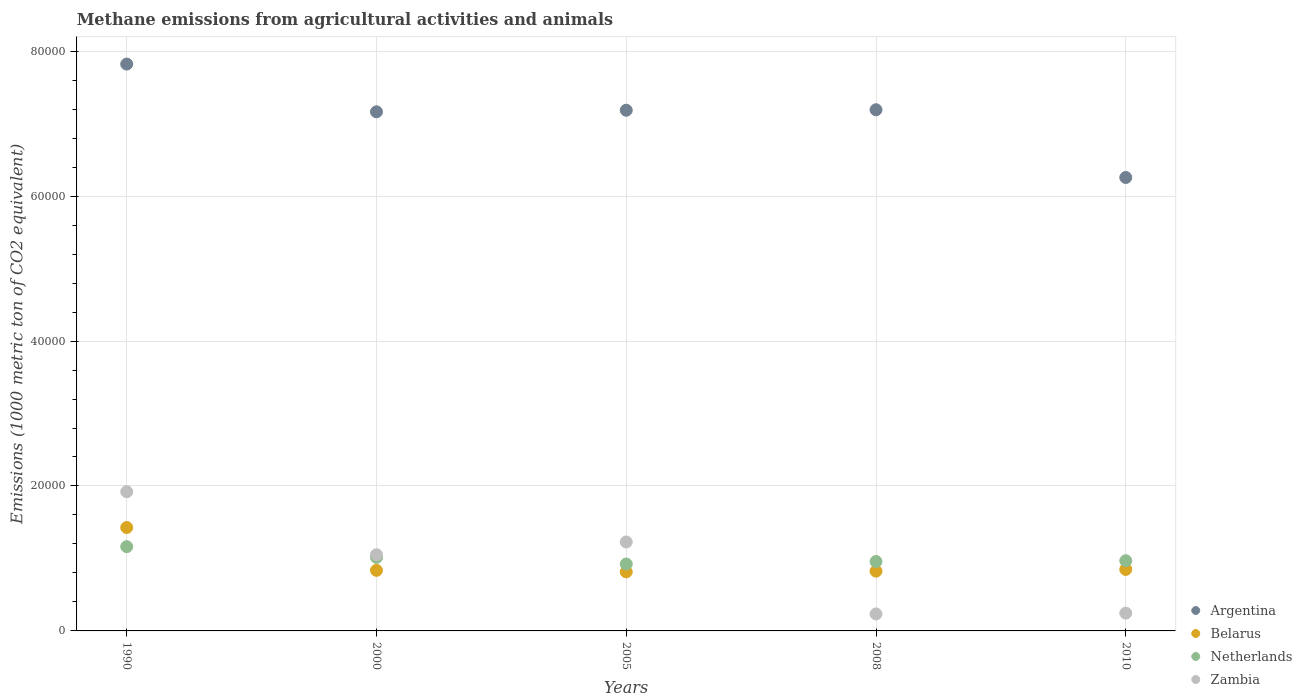What is the amount of methane emitted in Zambia in 2010?
Give a very brief answer. 2457.2. Across all years, what is the maximum amount of methane emitted in Zambia?
Provide a succinct answer. 1.92e+04. Across all years, what is the minimum amount of methane emitted in Netherlands?
Offer a very short reply. 9228. What is the total amount of methane emitted in Belarus in the graph?
Make the answer very short. 4.75e+04. What is the difference between the amount of methane emitted in Argentina in 1990 and that in 2000?
Your response must be concise. 6588.6. What is the difference between the amount of methane emitted in Zambia in 1990 and the amount of methane emitted in Netherlands in 2005?
Your answer should be compact. 9979.1. What is the average amount of methane emitted in Netherlands per year?
Keep it short and to the point. 1.01e+04. In the year 2005, what is the difference between the amount of methane emitted in Netherlands and amount of methane emitted in Zambia?
Make the answer very short. -3046.5. In how many years, is the amount of methane emitted in Argentina greater than 36000 1000 metric ton?
Provide a short and direct response. 5. What is the ratio of the amount of methane emitted in Argentina in 1990 to that in 2010?
Your response must be concise. 1.25. Is the amount of methane emitted in Netherlands in 2005 less than that in 2008?
Your answer should be compact. Yes. What is the difference between the highest and the second highest amount of methane emitted in Zambia?
Make the answer very short. 6932.6. What is the difference between the highest and the lowest amount of methane emitted in Belarus?
Give a very brief answer. 6122.6. In how many years, is the amount of methane emitted in Netherlands greater than the average amount of methane emitted in Netherlands taken over all years?
Give a very brief answer. 2. Is the sum of the amount of methane emitted in Belarus in 2005 and 2010 greater than the maximum amount of methane emitted in Argentina across all years?
Offer a very short reply. No. Is it the case that in every year, the sum of the amount of methane emitted in Argentina and amount of methane emitted in Zambia  is greater than the amount of methane emitted in Netherlands?
Your answer should be compact. Yes. Is the amount of methane emitted in Belarus strictly greater than the amount of methane emitted in Netherlands over the years?
Your response must be concise. No. Is the amount of methane emitted in Argentina strictly less than the amount of methane emitted in Zambia over the years?
Your answer should be very brief. No. How many years are there in the graph?
Provide a short and direct response. 5. Are the values on the major ticks of Y-axis written in scientific E-notation?
Your answer should be compact. No. Does the graph contain any zero values?
Make the answer very short. No. How many legend labels are there?
Your response must be concise. 4. What is the title of the graph?
Your response must be concise. Methane emissions from agricultural activities and animals. What is the label or title of the Y-axis?
Ensure brevity in your answer.  Emissions (1000 metric ton of CO2 equivalent). What is the Emissions (1000 metric ton of CO2 equivalent) of Argentina in 1990?
Your answer should be compact. 7.82e+04. What is the Emissions (1000 metric ton of CO2 equivalent) of Belarus in 1990?
Ensure brevity in your answer.  1.43e+04. What is the Emissions (1000 metric ton of CO2 equivalent) in Netherlands in 1990?
Offer a terse response. 1.16e+04. What is the Emissions (1000 metric ton of CO2 equivalent) in Zambia in 1990?
Your response must be concise. 1.92e+04. What is the Emissions (1000 metric ton of CO2 equivalent) of Argentina in 2000?
Ensure brevity in your answer.  7.16e+04. What is the Emissions (1000 metric ton of CO2 equivalent) in Belarus in 2000?
Ensure brevity in your answer.  8360.4. What is the Emissions (1000 metric ton of CO2 equivalent) of Netherlands in 2000?
Give a very brief answer. 1.01e+04. What is the Emissions (1000 metric ton of CO2 equivalent) of Zambia in 2000?
Ensure brevity in your answer.  1.05e+04. What is the Emissions (1000 metric ton of CO2 equivalent) in Argentina in 2005?
Ensure brevity in your answer.  7.19e+04. What is the Emissions (1000 metric ton of CO2 equivalent) of Belarus in 2005?
Your answer should be compact. 8147.7. What is the Emissions (1000 metric ton of CO2 equivalent) in Netherlands in 2005?
Provide a succinct answer. 9228. What is the Emissions (1000 metric ton of CO2 equivalent) in Zambia in 2005?
Provide a succinct answer. 1.23e+04. What is the Emissions (1000 metric ton of CO2 equivalent) of Argentina in 2008?
Your answer should be compact. 7.19e+04. What is the Emissions (1000 metric ton of CO2 equivalent) in Belarus in 2008?
Your answer should be compact. 8252. What is the Emissions (1000 metric ton of CO2 equivalent) of Netherlands in 2008?
Offer a terse response. 9574.5. What is the Emissions (1000 metric ton of CO2 equivalent) of Zambia in 2008?
Make the answer very short. 2342.5. What is the Emissions (1000 metric ton of CO2 equivalent) in Argentina in 2010?
Provide a short and direct response. 6.26e+04. What is the Emissions (1000 metric ton of CO2 equivalent) in Belarus in 2010?
Offer a very short reply. 8487.5. What is the Emissions (1000 metric ton of CO2 equivalent) in Netherlands in 2010?
Your answer should be compact. 9687.8. What is the Emissions (1000 metric ton of CO2 equivalent) of Zambia in 2010?
Offer a terse response. 2457.2. Across all years, what is the maximum Emissions (1000 metric ton of CO2 equivalent) in Argentina?
Provide a succinct answer. 7.82e+04. Across all years, what is the maximum Emissions (1000 metric ton of CO2 equivalent) of Belarus?
Provide a succinct answer. 1.43e+04. Across all years, what is the maximum Emissions (1000 metric ton of CO2 equivalent) in Netherlands?
Make the answer very short. 1.16e+04. Across all years, what is the maximum Emissions (1000 metric ton of CO2 equivalent) in Zambia?
Give a very brief answer. 1.92e+04. Across all years, what is the minimum Emissions (1000 metric ton of CO2 equivalent) of Argentina?
Provide a short and direct response. 6.26e+04. Across all years, what is the minimum Emissions (1000 metric ton of CO2 equivalent) in Belarus?
Your answer should be compact. 8147.7. Across all years, what is the minimum Emissions (1000 metric ton of CO2 equivalent) of Netherlands?
Keep it short and to the point. 9228. Across all years, what is the minimum Emissions (1000 metric ton of CO2 equivalent) of Zambia?
Offer a terse response. 2342.5. What is the total Emissions (1000 metric ton of CO2 equivalent) of Argentina in the graph?
Keep it short and to the point. 3.56e+05. What is the total Emissions (1000 metric ton of CO2 equivalent) in Belarus in the graph?
Offer a very short reply. 4.75e+04. What is the total Emissions (1000 metric ton of CO2 equivalent) in Netherlands in the graph?
Provide a succinct answer. 5.03e+04. What is the total Emissions (1000 metric ton of CO2 equivalent) of Zambia in the graph?
Provide a succinct answer. 4.68e+04. What is the difference between the Emissions (1000 metric ton of CO2 equivalent) of Argentina in 1990 and that in 2000?
Give a very brief answer. 6588.6. What is the difference between the Emissions (1000 metric ton of CO2 equivalent) of Belarus in 1990 and that in 2000?
Provide a succinct answer. 5909.9. What is the difference between the Emissions (1000 metric ton of CO2 equivalent) of Netherlands in 1990 and that in 2000?
Your answer should be very brief. 1481.2. What is the difference between the Emissions (1000 metric ton of CO2 equivalent) of Zambia in 1990 and that in 2000?
Ensure brevity in your answer.  8698.2. What is the difference between the Emissions (1000 metric ton of CO2 equivalent) of Argentina in 1990 and that in 2005?
Offer a terse response. 6369.6. What is the difference between the Emissions (1000 metric ton of CO2 equivalent) of Belarus in 1990 and that in 2005?
Give a very brief answer. 6122.6. What is the difference between the Emissions (1000 metric ton of CO2 equivalent) in Netherlands in 1990 and that in 2005?
Keep it short and to the point. 2398. What is the difference between the Emissions (1000 metric ton of CO2 equivalent) of Zambia in 1990 and that in 2005?
Provide a short and direct response. 6932.6. What is the difference between the Emissions (1000 metric ton of CO2 equivalent) in Argentina in 1990 and that in 2008?
Your answer should be very brief. 6305.5. What is the difference between the Emissions (1000 metric ton of CO2 equivalent) in Belarus in 1990 and that in 2008?
Your answer should be very brief. 6018.3. What is the difference between the Emissions (1000 metric ton of CO2 equivalent) in Netherlands in 1990 and that in 2008?
Your answer should be compact. 2051.5. What is the difference between the Emissions (1000 metric ton of CO2 equivalent) in Zambia in 1990 and that in 2008?
Offer a very short reply. 1.69e+04. What is the difference between the Emissions (1000 metric ton of CO2 equivalent) of Argentina in 1990 and that in 2010?
Make the answer very short. 1.57e+04. What is the difference between the Emissions (1000 metric ton of CO2 equivalent) of Belarus in 1990 and that in 2010?
Give a very brief answer. 5782.8. What is the difference between the Emissions (1000 metric ton of CO2 equivalent) of Netherlands in 1990 and that in 2010?
Provide a short and direct response. 1938.2. What is the difference between the Emissions (1000 metric ton of CO2 equivalent) in Zambia in 1990 and that in 2010?
Keep it short and to the point. 1.67e+04. What is the difference between the Emissions (1000 metric ton of CO2 equivalent) in Argentina in 2000 and that in 2005?
Your answer should be compact. -219. What is the difference between the Emissions (1000 metric ton of CO2 equivalent) of Belarus in 2000 and that in 2005?
Keep it short and to the point. 212.7. What is the difference between the Emissions (1000 metric ton of CO2 equivalent) in Netherlands in 2000 and that in 2005?
Provide a succinct answer. 916.8. What is the difference between the Emissions (1000 metric ton of CO2 equivalent) in Zambia in 2000 and that in 2005?
Provide a short and direct response. -1765.6. What is the difference between the Emissions (1000 metric ton of CO2 equivalent) of Argentina in 2000 and that in 2008?
Give a very brief answer. -283.1. What is the difference between the Emissions (1000 metric ton of CO2 equivalent) of Belarus in 2000 and that in 2008?
Your answer should be very brief. 108.4. What is the difference between the Emissions (1000 metric ton of CO2 equivalent) of Netherlands in 2000 and that in 2008?
Your response must be concise. 570.3. What is the difference between the Emissions (1000 metric ton of CO2 equivalent) of Zambia in 2000 and that in 2008?
Offer a very short reply. 8166.4. What is the difference between the Emissions (1000 metric ton of CO2 equivalent) of Argentina in 2000 and that in 2010?
Your response must be concise. 9062.7. What is the difference between the Emissions (1000 metric ton of CO2 equivalent) in Belarus in 2000 and that in 2010?
Your answer should be very brief. -127.1. What is the difference between the Emissions (1000 metric ton of CO2 equivalent) in Netherlands in 2000 and that in 2010?
Keep it short and to the point. 457. What is the difference between the Emissions (1000 metric ton of CO2 equivalent) of Zambia in 2000 and that in 2010?
Provide a short and direct response. 8051.7. What is the difference between the Emissions (1000 metric ton of CO2 equivalent) of Argentina in 2005 and that in 2008?
Provide a succinct answer. -64.1. What is the difference between the Emissions (1000 metric ton of CO2 equivalent) in Belarus in 2005 and that in 2008?
Your answer should be compact. -104.3. What is the difference between the Emissions (1000 metric ton of CO2 equivalent) in Netherlands in 2005 and that in 2008?
Provide a short and direct response. -346.5. What is the difference between the Emissions (1000 metric ton of CO2 equivalent) in Zambia in 2005 and that in 2008?
Provide a succinct answer. 9932. What is the difference between the Emissions (1000 metric ton of CO2 equivalent) of Argentina in 2005 and that in 2010?
Provide a short and direct response. 9281.7. What is the difference between the Emissions (1000 metric ton of CO2 equivalent) of Belarus in 2005 and that in 2010?
Ensure brevity in your answer.  -339.8. What is the difference between the Emissions (1000 metric ton of CO2 equivalent) of Netherlands in 2005 and that in 2010?
Offer a very short reply. -459.8. What is the difference between the Emissions (1000 metric ton of CO2 equivalent) of Zambia in 2005 and that in 2010?
Provide a short and direct response. 9817.3. What is the difference between the Emissions (1000 metric ton of CO2 equivalent) in Argentina in 2008 and that in 2010?
Your response must be concise. 9345.8. What is the difference between the Emissions (1000 metric ton of CO2 equivalent) of Belarus in 2008 and that in 2010?
Make the answer very short. -235.5. What is the difference between the Emissions (1000 metric ton of CO2 equivalent) in Netherlands in 2008 and that in 2010?
Keep it short and to the point. -113.3. What is the difference between the Emissions (1000 metric ton of CO2 equivalent) of Zambia in 2008 and that in 2010?
Your answer should be compact. -114.7. What is the difference between the Emissions (1000 metric ton of CO2 equivalent) of Argentina in 1990 and the Emissions (1000 metric ton of CO2 equivalent) of Belarus in 2000?
Keep it short and to the point. 6.99e+04. What is the difference between the Emissions (1000 metric ton of CO2 equivalent) of Argentina in 1990 and the Emissions (1000 metric ton of CO2 equivalent) of Netherlands in 2000?
Offer a very short reply. 6.81e+04. What is the difference between the Emissions (1000 metric ton of CO2 equivalent) of Argentina in 1990 and the Emissions (1000 metric ton of CO2 equivalent) of Zambia in 2000?
Ensure brevity in your answer.  6.77e+04. What is the difference between the Emissions (1000 metric ton of CO2 equivalent) in Belarus in 1990 and the Emissions (1000 metric ton of CO2 equivalent) in Netherlands in 2000?
Keep it short and to the point. 4125.5. What is the difference between the Emissions (1000 metric ton of CO2 equivalent) of Belarus in 1990 and the Emissions (1000 metric ton of CO2 equivalent) of Zambia in 2000?
Provide a succinct answer. 3761.4. What is the difference between the Emissions (1000 metric ton of CO2 equivalent) of Netherlands in 1990 and the Emissions (1000 metric ton of CO2 equivalent) of Zambia in 2000?
Ensure brevity in your answer.  1117.1. What is the difference between the Emissions (1000 metric ton of CO2 equivalent) of Argentina in 1990 and the Emissions (1000 metric ton of CO2 equivalent) of Belarus in 2005?
Offer a terse response. 7.01e+04. What is the difference between the Emissions (1000 metric ton of CO2 equivalent) in Argentina in 1990 and the Emissions (1000 metric ton of CO2 equivalent) in Netherlands in 2005?
Offer a very short reply. 6.90e+04. What is the difference between the Emissions (1000 metric ton of CO2 equivalent) in Argentina in 1990 and the Emissions (1000 metric ton of CO2 equivalent) in Zambia in 2005?
Give a very brief answer. 6.59e+04. What is the difference between the Emissions (1000 metric ton of CO2 equivalent) of Belarus in 1990 and the Emissions (1000 metric ton of CO2 equivalent) of Netherlands in 2005?
Offer a very short reply. 5042.3. What is the difference between the Emissions (1000 metric ton of CO2 equivalent) in Belarus in 1990 and the Emissions (1000 metric ton of CO2 equivalent) in Zambia in 2005?
Offer a terse response. 1995.8. What is the difference between the Emissions (1000 metric ton of CO2 equivalent) in Netherlands in 1990 and the Emissions (1000 metric ton of CO2 equivalent) in Zambia in 2005?
Give a very brief answer. -648.5. What is the difference between the Emissions (1000 metric ton of CO2 equivalent) of Argentina in 1990 and the Emissions (1000 metric ton of CO2 equivalent) of Belarus in 2008?
Offer a very short reply. 7.00e+04. What is the difference between the Emissions (1000 metric ton of CO2 equivalent) of Argentina in 1990 and the Emissions (1000 metric ton of CO2 equivalent) of Netherlands in 2008?
Make the answer very short. 6.86e+04. What is the difference between the Emissions (1000 metric ton of CO2 equivalent) of Argentina in 1990 and the Emissions (1000 metric ton of CO2 equivalent) of Zambia in 2008?
Offer a terse response. 7.59e+04. What is the difference between the Emissions (1000 metric ton of CO2 equivalent) in Belarus in 1990 and the Emissions (1000 metric ton of CO2 equivalent) in Netherlands in 2008?
Your answer should be very brief. 4695.8. What is the difference between the Emissions (1000 metric ton of CO2 equivalent) of Belarus in 1990 and the Emissions (1000 metric ton of CO2 equivalent) of Zambia in 2008?
Your answer should be compact. 1.19e+04. What is the difference between the Emissions (1000 metric ton of CO2 equivalent) in Netherlands in 1990 and the Emissions (1000 metric ton of CO2 equivalent) in Zambia in 2008?
Give a very brief answer. 9283.5. What is the difference between the Emissions (1000 metric ton of CO2 equivalent) in Argentina in 1990 and the Emissions (1000 metric ton of CO2 equivalent) in Belarus in 2010?
Provide a succinct answer. 6.97e+04. What is the difference between the Emissions (1000 metric ton of CO2 equivalent) of Argentina in 1990 and the Emissions (1000 metric ton of CO2 equivalent) of Netherlands in 2010?
Provide a short and direct response. 6.85e+04. What is the difference between the Emissions (1000 metric ton of CO2 equivalent) in Argentina in 1990 and the Emissions (1000 metric ton of CO2 equivalent) in Zambia in 2010?
Provide a succinct answer. 7.58e+04. What is the difference between the Emissions (1000 metric ton of CO2 equivalent) of Belarus in 1990 and the Emissions (1000 metric ton of CO2 equivalent) of Netherlands in 2010?
Make the answer very short. 4582.5. What is the difference between the Emissions (1000 metric ton of CO2 equivalent) in Belarus in 1990 and the Emissions (1000 metric ton of CO2 equivalent) in Zambia in 2010?
Provide a short and direct response. 1.18e+04. What is the difference between the Emissions (1000 metric ton of CO2 equivalent) of Netherlands in 1990 and the Emissions (1000 metric ton of CO2 equivalent) of Zambia in 2010?
Your answer should be very brief. 9168.8. What is the difference between the Emissions (1000 metric ton of CO2 equivalent) in Argentina in 2000 and the Emissions (1000 metric ton of CO2 equivalent) in Belarus in 2005?
Offer a terse response. 6.35e+04. What is the difference between the Emissions (1000 metric ton of CO2 equivalent) of Argentina in 2000 and the Emissions (1000 metric ton of CO2 equivalent) of Netherlands in 2005?
Provide a succinct answer. 6.24e+04. What is the difference between the Emissions (1000 metric ton of CO2 equivalent) in Argentina in 2000 and the Emissions (1000 metric ton of CO2 equivalent) in Zambia in 2005?
Your answer should be very brief. 5.94e+04. What is the difference between the Emissions (1000 metric ton of CO2 equivalent) in Belarus in 2000 and the Emissions (1000 metric ton of CO2 equivalent) in Netherlands in 2005?
Your answer should be very brief. -867.6. What is the difference between the Emissions (1000 metric ton of CO2 equivalent) of Belarus in 2000 and the Emissions (1000 metric ton of CO2 equivalent) of Zambia in 2005?
Your answer should be very brief. -3914.1. What is the difference between the Emissions (1000 metric ton of CO2 equivalent) of Netherlands in 2000 and the Emissions (1000 metric ton of CO2 equivalent) of Zambia in 2005?
Make the answer very short. -2129.7. What is the difference between the Emissions (1000 metric ton of CO2 equivalent) of Argentina in 2000 and the Emissions (1000 metric ton of CO2 equivalent) of Belarus in 2008?
Offer a terse response. 6.34e+04. What is the difference between the Emissions (1000 metric ton of CO2 equivalent) of Argentina in 2000 and the Emissions (1000 metric ton of CO2 equivalent) of Netherlands in 2008?
Offer a very short reply. 6.21e+04. What is the difference between the Emissions (1000 metric ton of CO2 equivalent) in Argentina in 2000 and the Emissions (1000 metric ton of CO2 equivalent) in Zambia in 2008?
Ensure brevity in your answer.  6.93e+04. What is the difference between the Emissions (1000 metric ton of CO2 equivalent) of Belarus in 2000 and the Emissions (1000 metric ton of CO2 equivalent) of Netherlands in 2008?
Give a very brief answer. -1214.1. What is the difference between the Emissions (1000 metric ton of CO2 equivalent) in Belarus in 2000 and the Emissions (1000 metric ton of CO2 equivalent) in Zambia in 2008?
Offer a very short reply. 6017.9. What is the difference between the Emissions (1000 metric ton of CO2 equivalent) in Netherlands in 2000 and the Emissions (1000 metric ton of CO2 equivalent) in Zambia in 2008?
Your response must be concise. 7802.3. What is the difference between the Emissions (1000 metric ton of CO2 equivalent) in Argentina in 2000 and the Emissions (1000 metric ton of CO2 equivalent) in Belarus in 2010?
Give a very brief answer. 6.31e+04. What is the difference between the Emissions (1000 metric ton of CO2 equivalent) in Argentina in 2000 and the Emissions (1000 metric ton of CO2 equivalent) in Netherlands in 2010?
Provide a succinct answer. 6.19e+04. What is the difference between the Emissions (1000 metric ton of CO2 equivalent) of Argentina in 2000 and the Emissions (1000 metric ton of CO2 equivalent) of Zambia in 2010?
Give a very brief answer. 6.92e+04. What is the difference between the Emissions (1000 metric ton of CO2 equivalent) of Belarus in 2000 and the Emissions (1000 metric ton of CO2 equivalent) of Netherlands in 2010?
Keep it short and to the point. -1327.4. What is the difference between the Emissions (1000 metric ton of CO2 equivalent) of Belarus in 2000 and the Emissions (1000 metric ton of CO2 equivalent) of Zambia in 2010?
Provide a succinct answer. 5903.2. What is the difference between the Emissions (1000 metric ton of CO2 equivalent) in Netherlands in 2000 and the Emissions (1000 metric ton of CO2 equivalent) in Zambia in 2010?
Offer a very short reply. 7687.6. What is the difference between the Emissions (1000 metric ton of CO2 equivalent) of Argentina in 2005 and the Emissions (1000 metric ton of CO2 equivalent) of Belarus in 2008?
Offer a very short reply. 6.36e+04. What is the difference between the Emissions (1000 metric ton of CO2 equivalent) in Argentina in 2005 and the Emissions (1000 metric ton of CO2 equivalent) in Netherlands in 2008?
Provide a succinct answer. 6.23e+04. What is the difference between the Emissions (1000 metric ton of CO2 equivalent) in Argentina in 2005 and the Emissions (1000 metric ton of CO2 equivalent) in Zambia in 2008?
Make the answer very short. 6.95e+04. What is the difference between the Emissions (1000 metric ton of CO2 equivalent) of Belarus in 2005 and the Emissions (1000 metric ton of CO2 equivalent) of Netherlands in 2008?
Keep it short and to the point. -1426.8. What is the difference between the Emissions (1000 metric ton of CO2 equivalent) in Belarus in 2005 and the Emissions (1000 metric ton of CO2 equivalent) in Zambia in 2008?
Keep it short and to the point. 5805.2. What is the difference between the Emissions (1000 metric ton of CO2 equivalent) of Netherlands in 2005 and the Emissions (1000 metric ton of CO2 equivalent) of Zambia in 2008?
Give a very brief answer. 6885.5. What is the difference between the Emissions (1000 metric ton of CO2 equivalent) in Argentina in 2005 and the Emissions (1000 metric ton of CO2 equivalent) in Belarus in 2010?
Give a very brief answer. 6.34e+04. What is the difference between the Emissions (1000 metric ton of CO2 equivalent) in Argentina in 2005 and the Emissions (1000 metric ton of CO2 equivalent) in Netherlands in 2010?
Keep it short and to the point. 6.22e+04. What is the difference between the Emissions (1000 metric ton of CO2 equivalent) of Argentina in 2005 and the Emissions (1000 metric ton of CO2 equivalent) of Zambia in 2010?
Make the answer very short. 6.94e+04. What is the difference between the Emissions (1000 metric ton of CO2 equivalent) in Belarus in 2005 and the Emissions (1000 metric ton of CO2 equivalent) in Netherlands in 2010?
Ensure brevity in your answer.  -1540.1. What is the difference between the Emissions (1000 metric ton of CO2 equivalent) of Belarus in 2005 and the Emissions (1000 metric ton of CO2 equivalent) of Zambia in 2010?
Keep it short and to the point. 5690.5. What is the difference between the Emissions (1000 metric ton of CO2 equivalent) of Netherlands in 2005 and the Emissions (1000 metric ton of CO2 equivalent) of Zambia in 2010?
Ensure brevity in your answer.  6770.8. What is the difference between the Emissions (1000 metric ton of CO2 equivalent) of Argentina in 2008 and the Emissions (1000 metric ton of CO2 equivalent) of Belarus in 2010?
Make the answer very short. 6.34e+04. What is the difference between the Emissions (1000 metric ton of CO2 equivalent) of Argentina in 2008 and the Emissions (1000 metric ton of CO2 equivalent) of Netherlands in 2010?
Your answer should be compact. 6.22e+04. What is the difference between the Emissions (1000 metric ton of CO2 equivalent) of Argentina in 2008 and the Emissions (1000 metric ton of CO2 equivalent) of Zambia in 2010?
Your response must be concise. 6.95e+04. What is the difference between the Emissions (1000 metric ton of CO2 equivalent) in Belarus in 2008 and the Emissions (1000 metric ton of CO2 equivalent) in Netherlands in 2010?
Ensure brevity in your answer.  -1435.8. What is the difference between the Emissions (1000 metric ton of CO2 equivalent) of Belarus in 2008 and the Emissions (1000 metric ton of CO2 equivalent) of Zambia in 2010?
Ensure brevity in your answer.  5794.8. What is the difference between the Emissions (1000 metric ton of CO2 equivalent) of Netherlands in 2008 and the Emissions (1000 metric ton of CO2 equivalent) of Zambia in 2010?
Offer a very short reply. 7117.3. What is the average Emissions (1000 metric ton of CO2 equivalent) of Argentina per year?
Your answer should be compact. 7.12e+04. What is the average Emissions (1000 metric ton of CO2 equivalent) in Belarus per year?
Your response must be concise. 9503.58. What is the average Emissions (1000 metric ton of CO2 equivalent) in Netherlands per year?
Give a very brief answer. 1.01e+04. What is the average Emissions (1000 metric ton of CO2 equivalent) of Zambia per year?
Provide a short and direct response. 9358.04. In the year 1990, what is the difference between the Emissions (1000 metric ton of CO2 equivalent) in Argentina and Emissions (1000 metric ton of CO2 equivalent) in Belarus?
Provide a succinct answer. 6.40e+04. In the year 1990, what is the difference between the Emissions (1000 metric ton of CO2 equivalent) in Argentina and Emissions (1000 metric ton of CO2 equivalent) in Netherlands?
Your answer should be compact. 6.66e+04. In the year 1990, what is the difference between the Emissions (1000 metric ton of CO2 equivalent) in Argentina and Emissions (1000 metric ton of CO2 equivalent) in Zambia?
Your answer should be very brief. 5.90e+04. In the year 1990, what is the difference between the Emissions (1000 metric ton of CO2 equivalent) of Belarus and Emissions (1000 metric ton of CO2 equivalent) of Netherlands?
Provide a short and direct response. 2644.3. In the year 1990, what is the difference between the Emissions (1000 metric ton of CO2 equivalent) of Belarus and Emissions (1000 metric ton of CO2 equivalent) of Zambia?
Offer a terse response. -4936.8. In the year 1990, what is the difference between the Emissions (1000 metric ton of CO2 equivalent) of Netherlands and Emissions (1000 metric ton of CO2 equivalent) of Zambia?
Provide a short and direct response. -7581.1. In the year 2000, what is the difference between the Emissions (1000 metric ton of CO2 equivalent) of Argentina and Emissions (1000 metric ton of CO2 equivalent) of Belarus?
Keep it short and to the point. 6.33e+04. In the year 2000, what is the difference between the Emissions (1000 metric ton of CO2 equivalent) of Argentina and Emissions (1000 metric ton of CO2 equivalent) of Netherlands?
Give a very brief answer. 6.15e+04. In the year 2000, what is the difference between the Emissions (1000 metric ton of CO2 equivalent) in Argentina and Emissions (1000 metric ton of CO2 equivalent) in Zambia?
Provide a succinct answer. 6.11e+04. In the year 2000, what is the difference between the Emissions (1000 metric ton of CO2 equivalent) of Belarus and Emissions (1000 metric ton of CO2 equivalent) of Netherlands?
Your answer should be very brief. -1784.4. In the year 2000, what is the difference between the Emissions (1000 metric ton of CO2 equivalent) of Belarus and Emissions (1000 metric ton of CO2 equivalent) of Zambia?
Make the answer very short. -2148.5. In the year 2000, what is the difference between the Emissions (1000 metric ton of CO2 equivalent) in Netherlands and Emissions (1000 metric ton of CO2 equivalent) in Zambia?
Offer a very short reply. -364.1. In the year 2005, what is the difference between the Emissions (1000 metric ton of CO2 equivalent) in Argentina and Emissions (1000 metric ton of CO2 equivalent) in Belarus?
Offer a terse response. 6.37e+04. In the year 2005, what is the difference between the Emissions (1000 metric ton of CO2 equivalent) of Argentina and Emissions (1000 metric ton of CO2 equivalent) of Netherlands?
Give a very brief answer. 6.26e+04. In the year 2005, what is the difference between the Emissions (1000 metric ton of CO2 equivalent) in Argentina and Emissions (1000 metric ton of CO2 equivalent) in Zambia?
Provide a short and direct response. 5.96e+04. In the year 2005, what is the difference between the Emissions (1000 metric ton of CO2 equivalent) in Belarus and Emissions (1000 metric ton of CO2 equivalent) in Netherlands?
Provide a succinct answer. -1080.3. In the year 2005, what is the difference between the Emissions (1000 metric ton of CO2 equivalent) of Belarus and Emissions (1000 metric ton of CO2 equivalent) of Zambia?
Offer a very short reply. -4126.8. In the year 2005, what is the difference between the Emissions (1000 metric ton of CO2 equivalent) of Netherlands and Emissions (1000 metric ton of CO2 equivalent) of Zambia?
Your answer should be very brief. -3046.5. In the year 2008, what is the difference between the Emissions (1000 metric ton of CO2 equivalent) in Argentina and Emissions (1000 metric ton of CO2 equivalent) in Belarus?
Provide a succinct answer. 6.37e+04. In the year 2008, what is the difference between the Emissions (1000 metric ton of CO2 equivalent) in Argentina and Emissions (1000 metric ton of CO2 equivalent) in Netherlands?
Offer a very short reply. 6.23e+04. In the year 2008, what is the difference between the Emissions (1000 metric ton of CO2 equivalent) of Argentina and Emissions (1000 metric ton of CO2 equivalent) of Zambia?
Offer a very short reply. 6.96e+04. In the year 2008, what is the difference between the Emissions (1000 metric ton of CO2 equivalent) in Belarus and Emissions (1000 metric ton of CO2 equivalent) in Netherlands?
Keep it short and to the point. -1322.5. In the year 2008, what is the difference between the Emissions (1000 metric ton of CO2 equivalent) of Belarus and Emissions (1000 metric ton of CO2 equivalent) of Zambia?
Your response must be concise. 5909.5. In the year 2008, what is the difference between the Emissions (1000 metric ton of CO2 equivalent) in Netherlands and Emissions (1000 metric ton of CO2 equivalent) in Zambia?
Your answer should be compact. 7232. In the year 2010, what is the difference between the Emissions (1000 metric ton of CO2 equivalent) in Argentina and Emissions (1000 metric ton of CO2 equivalent) in Belarus?
Offer a very short reply. 5.41e+04. In the year 2010, what is the difference between the Emissions (1000 metric ton of CO2 equivalent) of Argentina and Emissions (1000 metric ton of CO2 equivalent) of Netherlands?
Offer a very short reply. 5.29e+04. In the year 2010, what is the difference between the Emissions (1000 metric ton of CO2 equivalent) in Argentina and Emissions (1000 metric ton of CO2 equivalent) in Zambia?
Offer a very short reply. 6.01e+04. In the year 2010, what is the difference between the Emissions (1000 metric ton of CO2 equivalent) in Belarus and Emissions (1000 metric ton of CO2 equivalent) in Netherlands?
Your answer should be compact. -1200.3. In the year 2010, what is the difference between the Emissions (1000 metric ton of CO2 equivalent) in Belarus and Emissions (1000 metric ton of CO2 equivalent) in Zambia?
Ensure brevity in your answer.  6030.3. In the year 2010, what is the difference between the Emissions (1000 metric ton of CO2 equivalent) of Netherlands and Emissions (1000 metric ton of CO2 equivalent) of Zambia?
Your answer should be compact. 7230.6. What is the ratio of the Emissions (1000 metric ton of CO2 equivalent) in Argentina in 1990 to that in 2000?
Keep it short and to the point. 1.09. What is the ratio of the Emissions (1000 metric ton of CO2 equivalent) of Belarus in 1990 to that in 2000?
Your response must be concise. 1.71. What is the ratio of the Emissions (1000 metric ton of CO2 equivalent) in Netherlands in 1990 to that in 2000?
Give a very brief answer. 1.15. What is the ratio of the Emissions (1000 metric ton of CO2 equivalent) in Zambia in 1990 to that in 2000?
Provide a succinct answer. 1.83. What is the ratio of the Emissions (1000 metric ton of CO2 equivalent) of Argentina in 1990 to that in 2005?
Provide a short and direct response. 1.09. What is the ratio of the Emissions (1000 metric ton of CO2 equivalent) in Belarus in 1990 to that in 2005?
Provide a short and direct response. 1.75. What is the ratio of the Emissions (1000 metric ton of CO2 equivalent) of Netherlands in 1990 to that in 2005?
Provide a short and direct response. 1.26. What is the ratio of the Emissions (1000 metric ton of CO2 equivalent) in Zambia in 1990 to that in 2005?
Offer a very short reply. 1.56. What is the ratio of the Emissions (1000 metric ton of CO2 equivalent) of Argentina in 1990 to that in 2008?
Your response must be concise. 1.09. What is the ratio of the Emissions (1000 metric ton of CO2 equivalent) in Belarus in 1990 to that in 2008?
Your answer should be compact. 1.73. What is the ratio of the Emissions (1000 metric ton of CO2 equivalent) in Netherlands in 1990 to that in 2008?
Your response must be concise. 1.21. What is the ratio of the Emissions (1000 metric ton of CO2 equivalent) in Zambia in 1990 to that in 2008?
Offer a terse response. 8.2. What is the ratio of the Emissions (1000 metric ton of CO2 equivalent) of Argentina in 1990 to that in 2010?
Your response must be concise. 1.25. What is the ratio of the Emissions (1000 metric ton of CO2 equivalent) in Belarus in 1990 to that in 2010?
Make the answer very short. 1.68. What is the ratio of the Emissions (1000 metric ton of CO2 equivalent) in Netherlands in 1990 to that in 2010?
Offer a terse response. 1.2. What is the ratio of the Emissions (1000 metric ton of CO2 equivalent) of Zambia in 1990 to that in 2010?
Give a very brief answer. 7.82. What is the ratio of the Emissions (1000 metric ton of CO2 equivalent) in Argentina in 2000 to that in 2005?
Your answer should be very brief. 1. What is the ratio of the Emissions (1000 metric ton of CO2 equivalent) in Belarus in 2000 to that in 2005?
Give a very brief answer. 1.03. What is the ratio of the Emissions (1000 metric ton of CO2 equivalent) of Netherlands in 2000 to that in 2005?
Offer a terse response. 1.1. What is the ratio of the Emissions (1000 metric ton of CO2 equivalent) in Zambia in 2000 to that in 2005?
Offer a very short reply. 0.86. What is the ratio of the Emissions (1000 metric ton of CO2 equivalent) of Argentina in 2000 to that in 2008?
Ensure brevity in your answer.  1. What is the ratio of the Emissions (1000 metric ton of CO2 equivalent) in Belarus in 2000 to that in 2008?
Ensure brevity in your answer.  1.01. What is the ratio of the Emissions (1000 metric ton of CO2 equivalent) in Netherlands in 2000 to that in 2008?
Ensure brevity in your answer.  1.06. What is the ratio of the Emissions (1000 metric ton of CO2 equivalent) in Zambia in 2000 to that in 2008?
Offer a very short reply. 4.49. What is the ratio of the Emissions (1000 metric ton of CO2 equivalent) of Argentina in 2000 to that in 2010?
Your response must be concise. 1.14. What is the ratio of the Emissions (1000 metric ton of CO2 equivalent) in Belarus in 2000 to that in 2010?
Your answer should be compact. 0.98. What is the ratio of the Emissions (1000 metric ton of CO2 equivalent) in Netherlands in 2000 to that in 2010?
Ensure brevity in your answer.  1.05. What is the ratio of the Emissions (1000 metric ton of CO2 equivalent) in Zambia in 2000 to that in 2010?
Give a very brief answer. 4.28. What is the ratio of the Emissions (1000 metric ton of CO2 equivalent) in Belarus in 2005 to that in 2008?
Make the answer very short. 0.99. What is the ratio of the Emissions (1000 metric ton of CO2 equivalent) in Netherlands in 2005 to that in 2008?
Give a very brief answer. 0.96. What is the ratio of the Emissions (1000 metric ton of CO2 equivalent) in Zambia in 2005 to that in 2008?
Keep it short and to the point. 5.24. What is the ratio of the Emissions (1000 metric ton of CO2 equivalent) of Argentina in 2005 to that in 2010?
Offer a very short reply. 1.15. What is the ratio of the Emissions (1000 metric ton of CO2 equivalent) of Netherlands in 2005 to that in 2010?
Your answer should be very brief. 0.95. What is the ratio of the Emissions (1000 metric ton of CO2 equivalent) in Zambia in 2005 to that in 2010?
Ensure brevity in your answer.  5. What is the ratio of the Emissions (1000 metric ton of CO2 equivalent) in Argentina in 2008 to that in 2010?
Offer a very short reply. 1.15. What is the ratio of the Emissions (1000 metric ton of CO2 equivalent) of Belarus in 2008 to that in 2010?
Offer a terse response. 0.97. What is the ratio of the Emissions (1000 metric ton of CO2 equivalent) of Netherlands in 2008 to that in 2010?
Make the answer very short. 0.99. What is the ratio of the Emissions (1000 metric ton of CO2 equivalent) of Zambia in 2008 to that in 2010?
Ensure brevity in your answer.  0.95. What is the difference between the highest and the second highest Emissions (1000 metric ton of CO2 equivalent) of Argentina?
Keep it short and to the point. 6305.5. What is the difference between the highest and the second highest Emissions (1000 metric ton of CO2 equivalent) in Belarus?
Keep it short and to the point. 5782.8. What is the difference between the highest and the second highest Emissions (1000 metric ton of CO2 equivalent) of Netherlands?
Keep it short and to the point. 1481.2. What is the difference between the highest and the second highest Emissions (1000 metric ton of CO2 equivalent) in Zambia?
Ensure brevity in your answer.  6932.6. What is the difference between the highest and the lowest Emissions (1000 metric ton of CO2 equivalent) in Argentina?
Offer a terse response. 1.57e+04. What is the difference between the highest and the lowest Emissions (1000 metric ton of CO2 equivalent) of Belarus?
Keep it short and to the point. 6122.6. What is the difference between the highest and the lowest Emissions (1000 metric ton of CO2 equivalent) in Netherlands?
Ensure brevity in your answer.  2398. What is the difference between the highest and the lowest Emissions (1000 metric ton of CO2 equivalent) of Zambia?
Ensure brevity in your answer.  1.69e+04. 